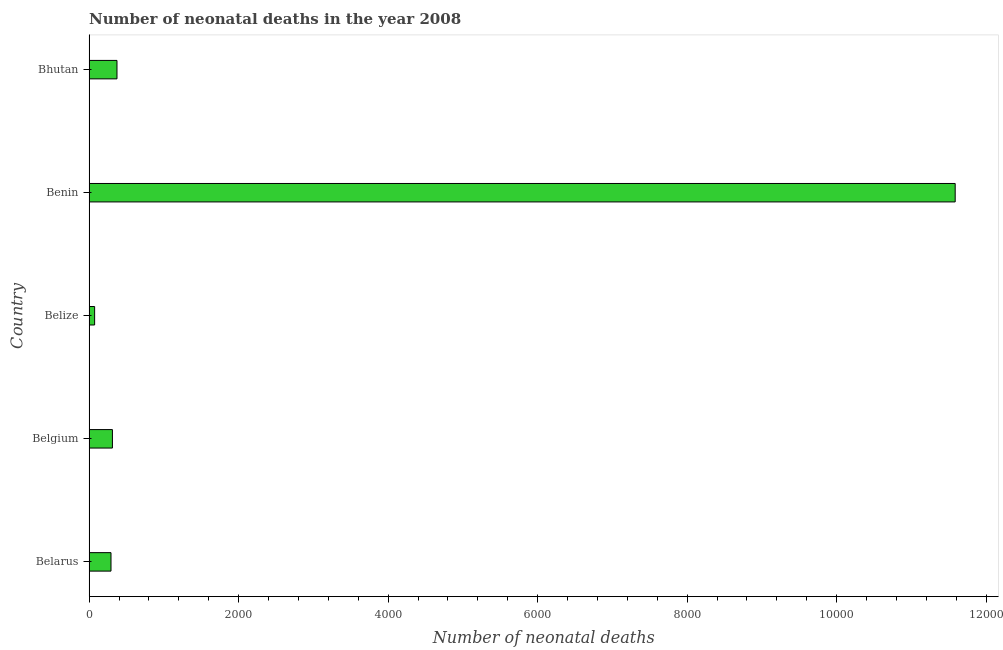Does the graph contain any zero values?
Offer a very short reply. No. Does the graph contain grids?
Make the answer very short. No. What is the title of the graph?
Provide a short and direct response. Number of neonatal deaths in the year 2008. What is the label or title of the X-axis?
Offer a terse response. Number of neonatal deaths. What is the number of neonatal deaths in Belgium?
Your answer should be very brief. 312. Across all countries, what is the maximum number of neonatal deaths?
Offer a terse response. 1.16e+04. Across all countries, what is the minimum number of neonatal deaths?
Offer a very short reply. 74. In which country was the number of neonatal deaths maximum?
Your answer should be very brief. Benin. In which country was the number of neonatal deaths minimum?
Provide a short and direct response. Belize. What is the sum of the number of neonatal deaths?
Give a very brief answer. 1.26e+04. What is the difference between the number of neonatal deaths in Belarus and Belgium?
Offer a terse response. -19. What is the average number of neonatal deaths per country?
Your answer should be compact. 2527. What is the median number of neonatal deaths?
Your answer should be very brief. 312. In how many countries, is the number of neonatal deaths greater than 9600 ?
Offer a very short reply. 1. What is the ratio of the number of neonatal deaths in Belarus to that in Belize?
Ensure brevity in your answer.  3.96. What is the difference between the highest and the second highest number of neonatal deaths?
Your answer should be compact. 1.12e+04. What is the difference between the highest and the lowest number of neonatal deaths?
Make the answer very short. 1.15e+04. How many bars are there?
Your answer should be compact. 5. How many countries are there in the graph?
Make the answer very short. 5. What is the difference between two consecutive major ticks on the X-axis?
Keep it short and to the point. 2000. Are the values on the major ticks of X-axis written in scientific E-notation?
Your response must be concise. No. What is the Number of neonatal deaths of Belarus?
Make the answer very short. 293. What is the Number of neonatal deaths of Belgium?
Offer a terse response. 312. What is the Number of neonatal deaths of Benin?
Your answer should be very brief. 1.16e+04. What is the Number of neonatal deaths of Bhutan?
Ensure brevity in your answer.  373. What is the difference between the Number of neonatal deaths in Belarus and Belize?
Give a very brief answer. 219. What is the difference between the Number of neonatal deaths in Belarus and Benin?
Keep it short and to the point. -1.13e+04. What is the difference between the Number of neonatal deaths in Belarus and Bhutan?
Your response must be concise. -80. What is the difference between the Number of neonatal deaths in Belgium and Belize?
Keep it short and to the point. 238. What is the difference between the Number of neonatal deaths in Belgium and Benin?
Your response must be concise. -1.13e+04. What is the difference between the Number of neonatal deaths in Belgium and Bhutan?
Provide a short and direct response. -61. What is the difference between the Number of neonatal deaths in Belize and Benin?
Make the answer very short. -1.15e+04. What is the difference between the Number of neonatal deaths in Belize and Bhutan?
Provide a succinct answer. -299. What is the difference between the Number of neonatal deaths in Benin and Bhutan?
Offer a very short reply. 1.12e+04. What is the ratio of the Number of neonatal deaths in Belarus to that in Belgium?
Your response must be concise. 0.94. What is the ratio of the Number of neonatal deaths in Belarus to that in Belize?
Make the answer very short. 3.96. What is the ratio of the Number of neonatal deaths in Belarus to that in Benin?
Keep it short and to the point. 0.03. What is the ratio of the Number of neonatal deaths in Belarus to that in Bhutan?
Provide a succinct answer. 0.79. What is the ratio of the Number of neonatal deaths in Belgium to that in Belize?
Offer a terse response. 4.22. What is the ratio of the Number of neonatal deaths in Belgium to that in Benin?
Ensure brevity in your answer.  0.03. What is the ratio of the Number of neonatal deaths in Belgium to that in Bhutan?
Offer a terse response. 0.84. What is the ratio of the Number of neonatal deaths in Belize to that in Benin?
Ensure brevity in your answer.  0.01. What is the ratio of the Number of neonatal deaths in Belize to that in Bhutan?
Ensure brevity in your answer.  0.2. What is the ratio of the Number of neonatal deaths in Benin to that in Bhutan?
Make the answer very short. 31.06. 